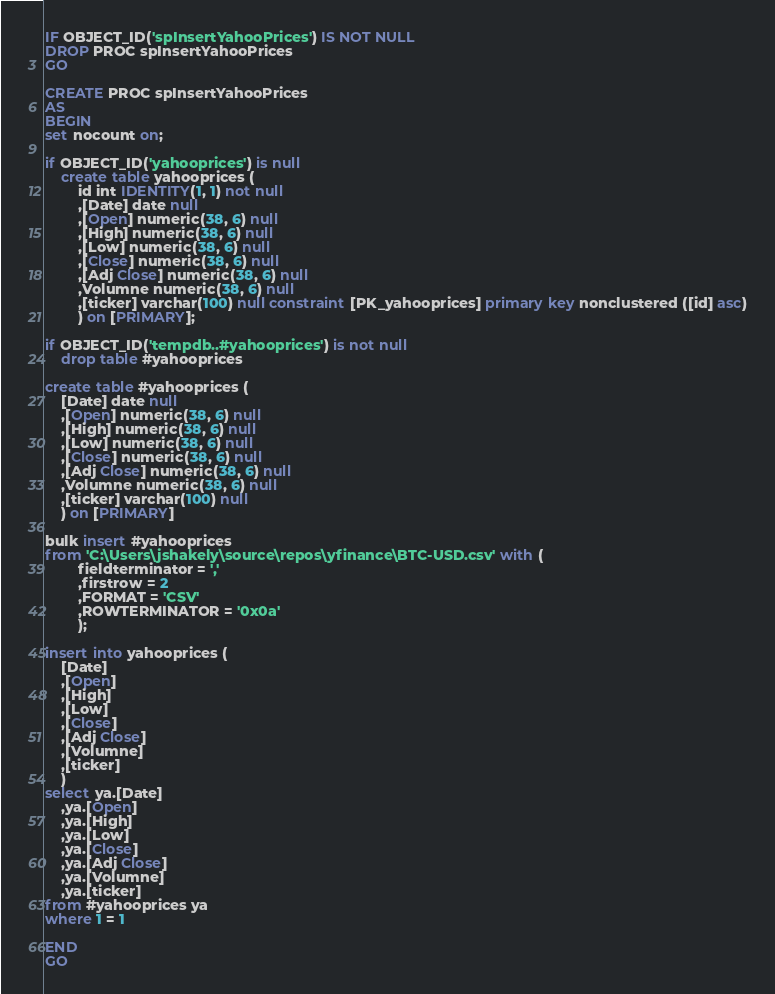<code> <loc_0><loc_0><loc_500><loc_500><_SQL_>IF OBJECT_ID('spInsertYahooPrices') IS NOT NULL 
DROP PROC spInsertYahooPrices
GO

CREATE PROC spInsertYahooPrices
AS 
BEGIN 
set nocount on;

if OBJECT_ID('yahooprices') is null
	create table yahooprices (
		id int IDENTITY(1, 1) not null
		,[Date] date null
		,[Open] numeric(38, 6) null
		,[High] numeric(38, 6) null
		,[Low] numeric(38, 6) null
		,[Close] numeric(38, 6) null
		,[Adj Close] numeric(38, 6) null
		,Volumne numeric(38, 6) null
		,[ticker] varchar(100) null constraint [PK_yahooprices] primary key nonclustered ([id] asc)
		) on [PRIMARY];

if OBJECT_ID('tempdb..#yahooprices') is not null
	drop table #yahooprices

create table #yahooprices (
	[Date] date null
	,[Open] numeric(38, 6) null
	,[High] numeric(38, 6) null
	,[Low] numeric(38, 6) null
	,[Close] numeric(38, 6) null
	,[Adj Close] numeric(38, 6) null
	,Volumne numeric(38, 6) null
	,[ticker] varchar(100) null
	) on [PRIMARY]

bulk insert #yahooprices
from 'C:\Users\jshakely\source\repos\yfinance\BTC-USD.csv' with (
		fieldterminator = ','
		,firstrow = 2
		,FORMAT = 'CSV'
		,ROWTERMINATOR = '0x0a'
		);

insert into yahooprices (
	[Date]
	,[Open]
	,[High]
	,[Low]
	,[Close]
	,[Adj Close]
	,[Volumne]
	,[ticker]
	)
select ya.[Date]
	,ya.[Open]
	,ya.[High]
	,ya.[Low]
	,ya.[Close]
	,ya.[Adj Close]
	,ya.[Volumne]
	,ya.[ticker]
from #yahooprices ya
where 1 = 1

END
GO</code> 